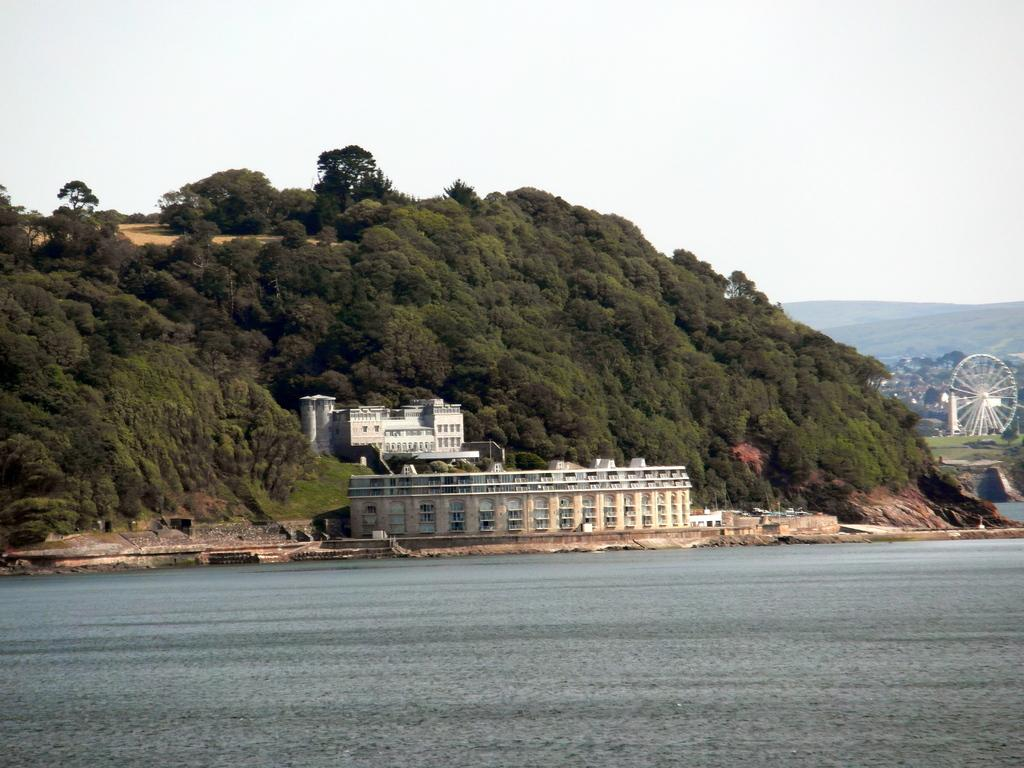What can be seen in the sky in the image? The sky is visible in the image. What type of natural landform is present in the image? There are hills in the image. What type of vegetation is present in the image? Trees and grass are present in the image. What type of structures are present in the image? There are buildings in the image. What type of body of water is visible in the image? Water is visible in the image. What type of transportation equipment is present in the image? There is a joint wheel in the image. What type of shoes can be seen on the trees in the image? There are no shoes present in the image, and shoes are not typically found on trees. Is there a crib visible in the image? There is no crib present in the image. 